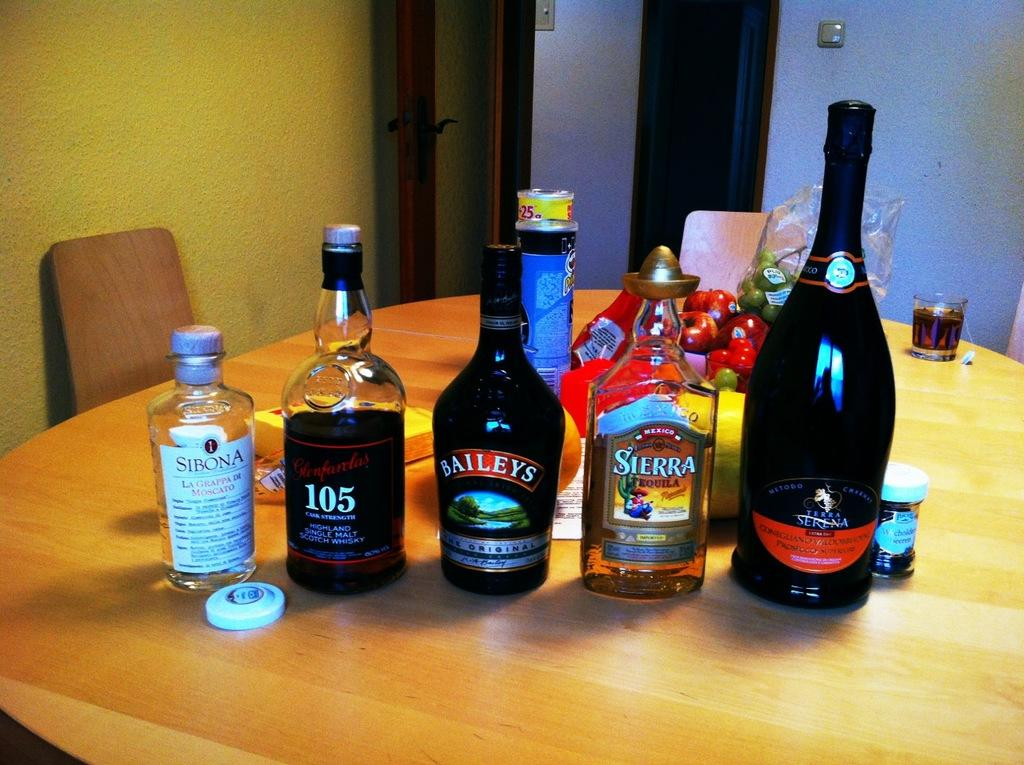Provide a one-sentence caption for the provided image. Several bottles from sitting on a table including Bailey's, Sierra, 105 and Sibona. 